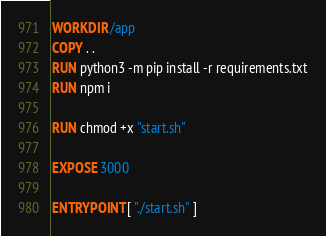Convert code to text. <code><loc_0><loc_0><loc_500><loc_500><_Dockerfile_>WORKDIR /app
COPY . .
RUN python3 -m pip install -r requirements.txt
RUN npm i

RUN chmod +x "start.sh"

EXPOSE 3000

ENTRYPOINT [ "./start.sh" ]
</code> 